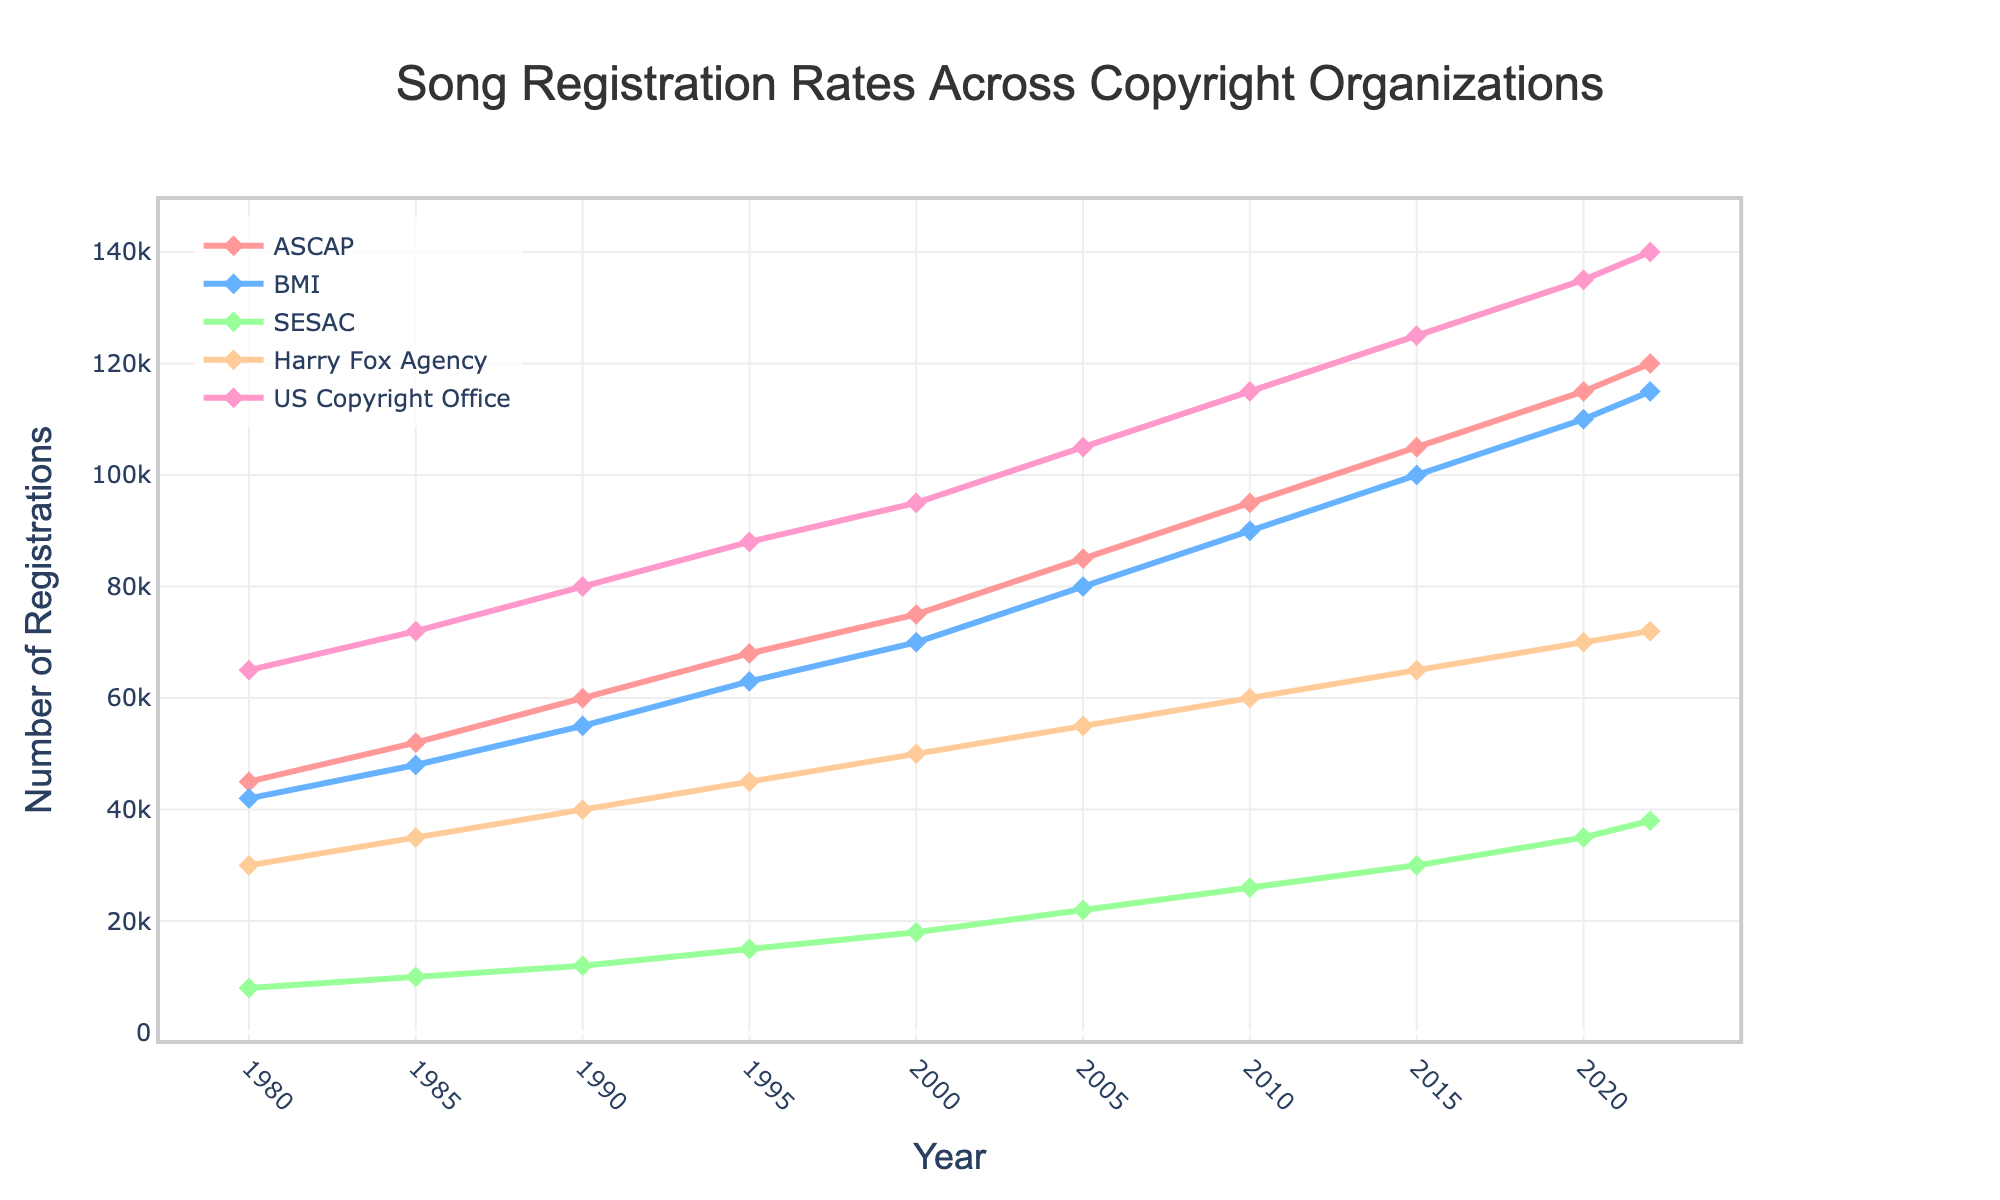What is the trend of song registrations with the US Copyright Office from 1980 to 2022? The number of song registrations with the US Copyright Office increased consistently over the years. Starting from 65,000 registrations in 1980, it reached 140,000 registrations in 2022, showing a steady upward trend across the period.
Answer: Steady increase Which organization had the highest number of song registrations in 2022? By looking at the 2022 data point, the US Copyright Office had the highest number of song registrations, with 140,000 registrations.
Answer: US Copyright Office How do the song registration rates of ASCAP and BMI compare in 1990? In 1990, ASCAP had 60,000 registrations while BMI had 55,000 registrations. Calculating the difference, ASCAP had 5,000 more registrations than BMI that year.
Answer: ASCAP had 5,000 more registrations What is the difference in the number of song registrations between SESAC and Harry Fox Agency in 2005? In 2005, SESAC had 22,000 song registrations and Harry Fox Agency had 55,000 registrations. The difference in the number of registrations is 55,000 - 22,000 = 33,000.
Answer: 33,000 What is the average number of song registrations for BMI between 1980 and 2022? To find the average, sum up BMI's registration numbers for each year given and divide by the total number of years:
(42,000 + 48,000 + 55,000 + 63,000 + 70,000 + 80,000 + 90,000 + 100,000 + 110,000 + 115,000) / 10 = 733,000 / 10 = 73,300.
Answer: 73,300 What is the median number of song registrations for Harry Fox Agency between 1980 and 2022? Arrange Harry Fox Agency's registration numbers in ascending order and find the middle value:
(30,000, 35,000, 40,000, 45,000, 50,000, 55,000, 60,000, 65,000, 70,000, 72,000)
With an even number of data points, the median will be the average of the 5th and 6th values: (50,000 + 55,000) / 2 = 52,500.
Answer: 52,500 Which organization consistently follows an orange-colored line? Organizations are represented by different colored lines and markers. To identify which organization has an orange-colored line, we just need to refer to the color scheme in the plot. The Harry Fox Agency is indicated by the orange line.
Answer: Harry Fox Agency How did the song registration rates for ASCAP and SESAC evolve from 2000 to 2010? Comparing 2000 and 2010:
- ASCAP went from 75,000 to 95,000.
- SESAC went from 18,000 to 26,000.
Both organizations saw an increase in registrations, with ASCAP increasing by 20,000 and SESAC increasing by 8,000.
Answer: Both increased (ASCAP by 20,000, SESAC by 8,000) 